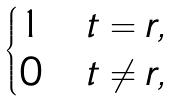Convert formula to latex. <formula><loc_0><loc_0><loc_500><loc_500>\begin{cases} 1 & t = r , \\ 0 & t \neq r , \end{cases}</formula> 